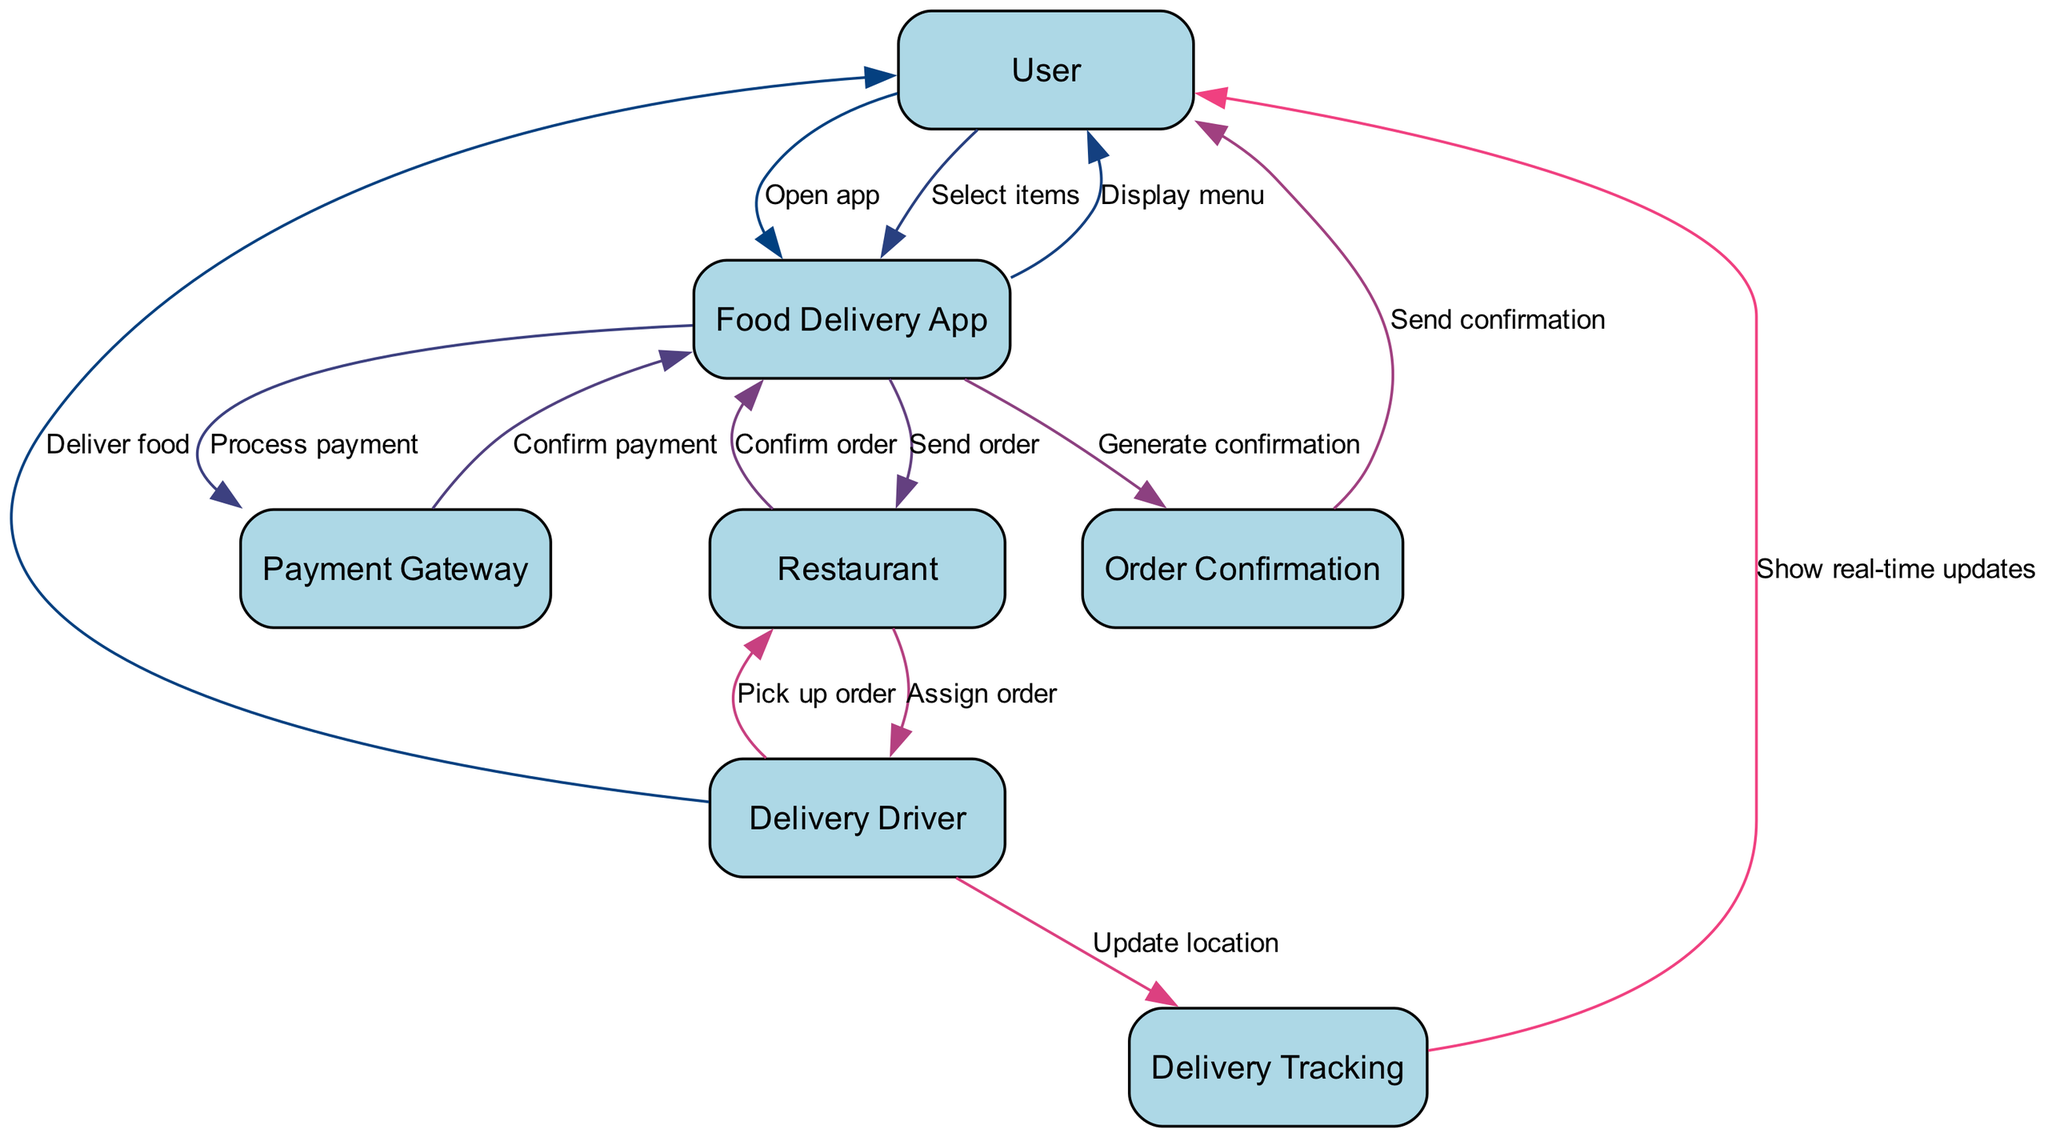What is the total number of nodes in the diagram? The diagram consists of six unique elements: User, Food Delivery App, Restaurant, Payment Gateway, Delivery Driver, and Order Confirmation, along with Delivery Tracking, which makes a total of seven nodes.
Answer: seven What is the first action taken by the User? The first action in the sequence diagram is when the User opens the Food Delivery App. This can be identified as the first interaction in the flow from the User to the Food Delivery App.
Answer: Open app Which node confirms the payment? The Payment Gateway confirms the payment. This is indicated in the sequence where the Food Delivery App sends a payment processing request to the Payment Gateway, which then responds to confirm the payment.
Answer: Payment Gateway Who delivers the food to the User? The Delivery Driver delivers the food to the User. This can be established from the sequence where the Delivery Driver is the final actor in the flow, indicated by the action of delivering food to the User.
Answer: Delivery Driver What action is taken after the Restaurant confirms the order? After the Restaurant confirms the order, the Food Delivery App generates an order confirmation, which is represented by the action immediately following the Restaurant acknowledging the order.
Answer: Generate confirmation What type of updates can the User see on the Delivery Tracking? The User can see real-time updates on the Delivery Tracking feature, which is designed to show the live status of their food delivery. This can be concluded from the action taken where Delivery Tracking shows updates to the User.
Answer: real-time updates What happens after the Delivery Driver picks up the order? Following the Delivery Driver picking up the order, the Delivery Driver updates their location on the Delivery Tracking feature. This step is clearly defined in the sequence after the pickup action.
Answer: Update location Which node sends the order to the Restaurant? The Food Delivery App is responsible for sending the order to the Restaurant, which is established in the action sequence that directly links the Food Delivery App with the Restaurant.
Answer: Food Delivery App 